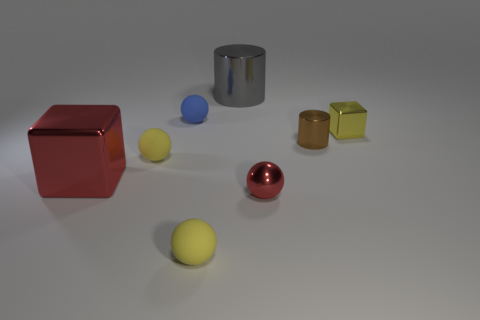Add 1 gray metal cylinders. How many objects exist? 9 Subtract 1 spheres. How many spheres are left? 3 Subtract all small shiny spheres. How many spheres are left? 3 Add 7 large gray objects. How many large gray objects exist? 8 Subtract all brown cylinders. How many cylinders are left? 1 Subtract 0 blue cubes. How many objects are left? 8 Subtract all cylinders. How many objects are left? 6 Subtract all gray cylinders. Subtract all purple blocks. How many cylinders are left? 1 Subtract all blue cylinders. How many red balls are left? 1 Subtract all small metal cubes. Subtract all small green objects. How many objects are left? 7 